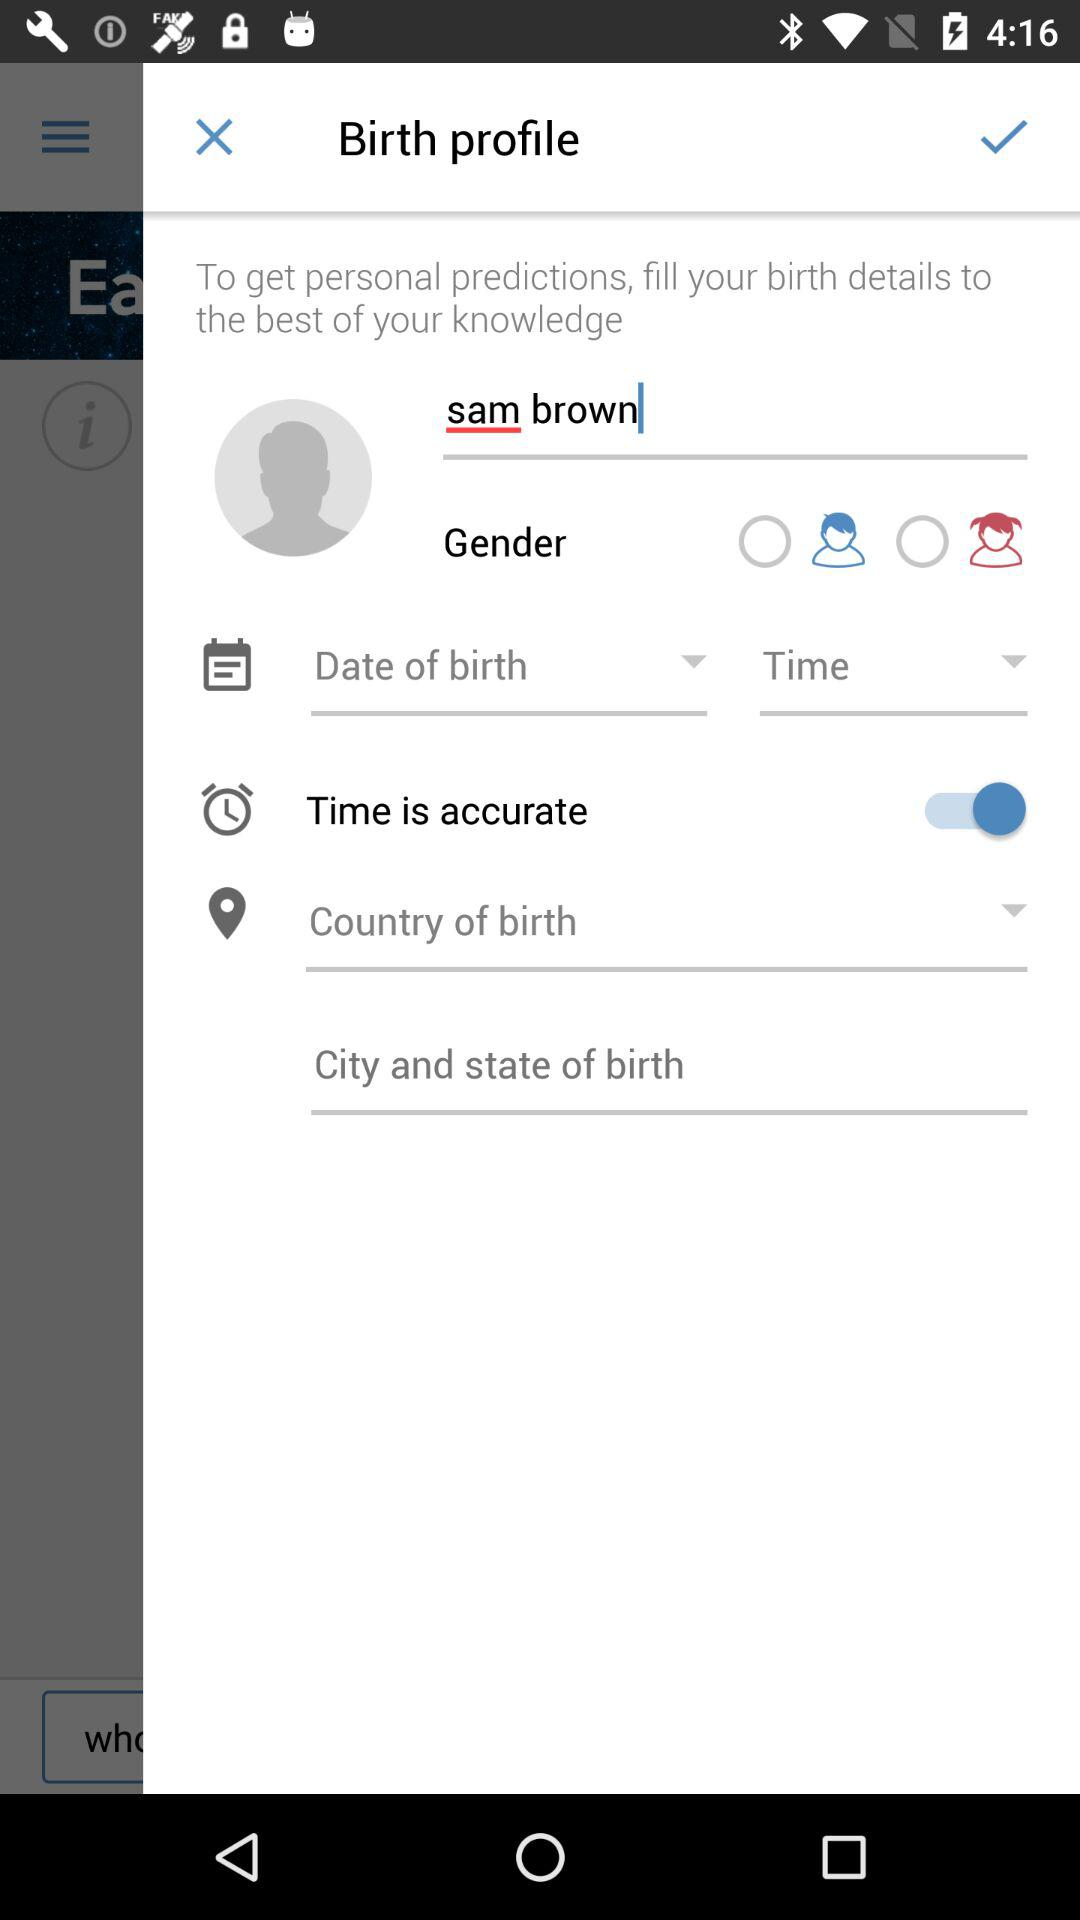What is the status of "Time is accurate"? The status is "on". 